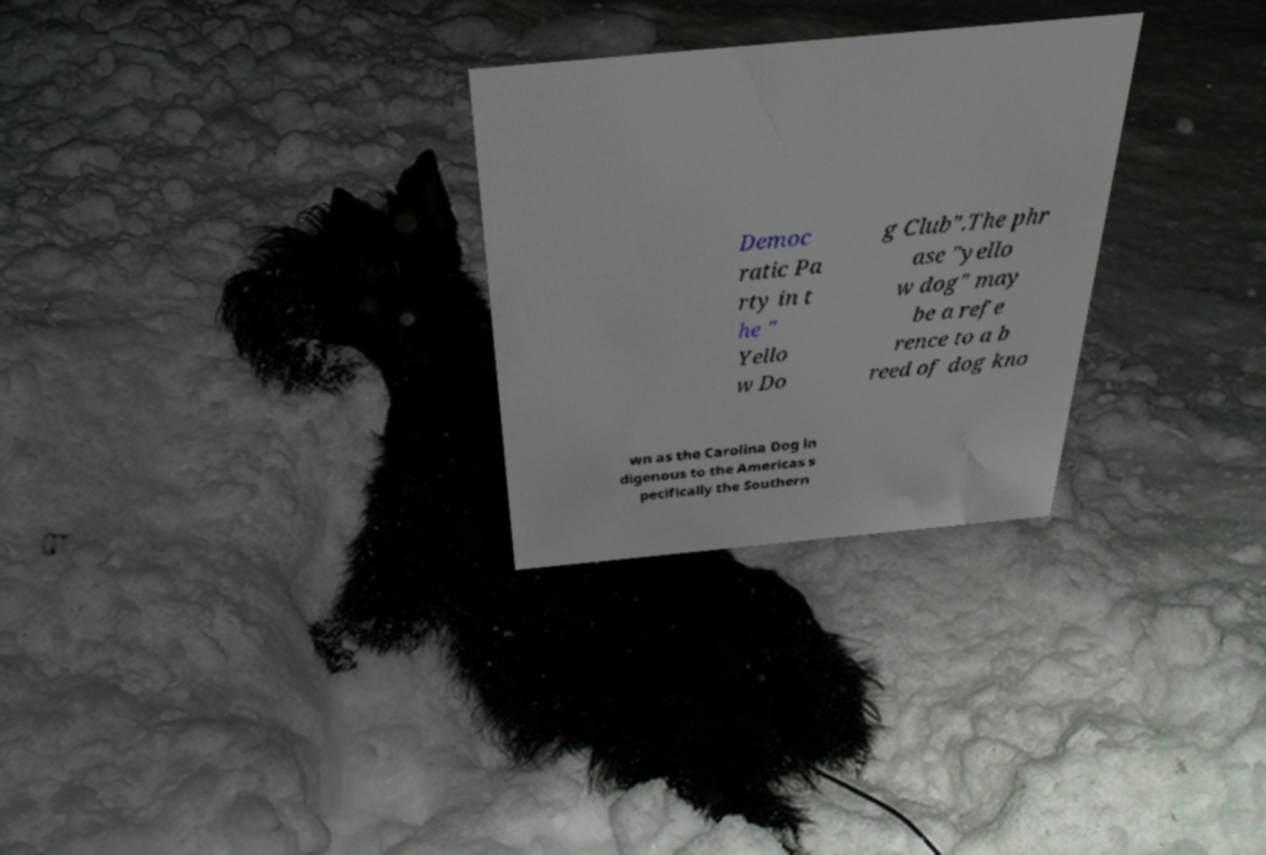Could you extract and type out the text from this image? Democ ratic Pa rty in t he " Yello w Do g Club".The phr ase "yello w dog" may be a refe rence to a b reed of dog kno wn as the Carolina Dog in digenous to the Americas s pecifically the Southern 